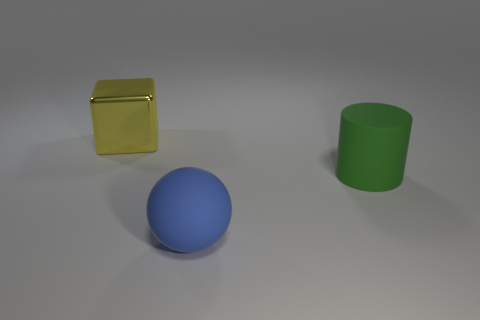Add 3 yellow cubes. How many objects exist? 6 Subtract all cylinders. How many objects are left? 2 Add 3 spheres. How many spheres exist? 4 Subtract 0 gray balls. How many objects are left? 3 Subtract all cubes. Subtract all blue matte spheres. How many objects are left? 1 Add 3 large blocks. How many large blocks are left? 4 